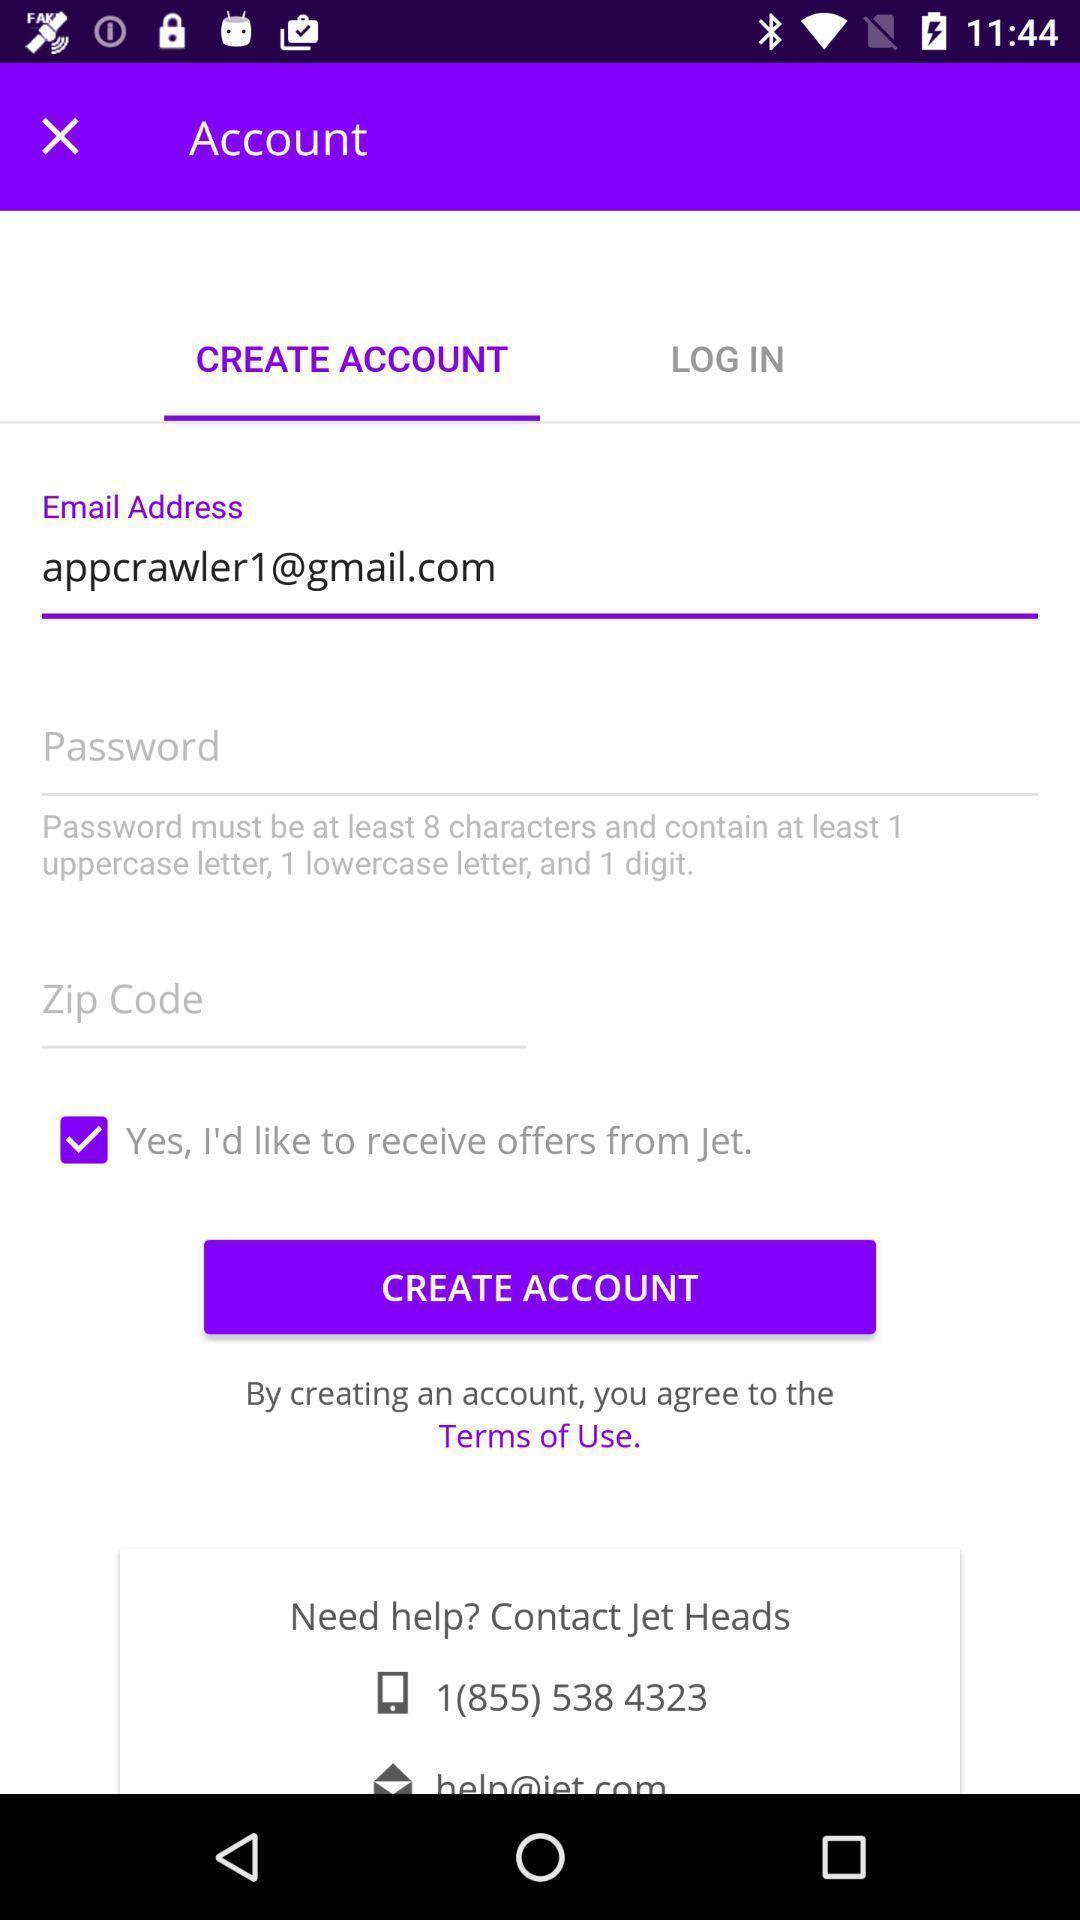Describe the visual elements of this screenshot. Page displays to create an account in app. 